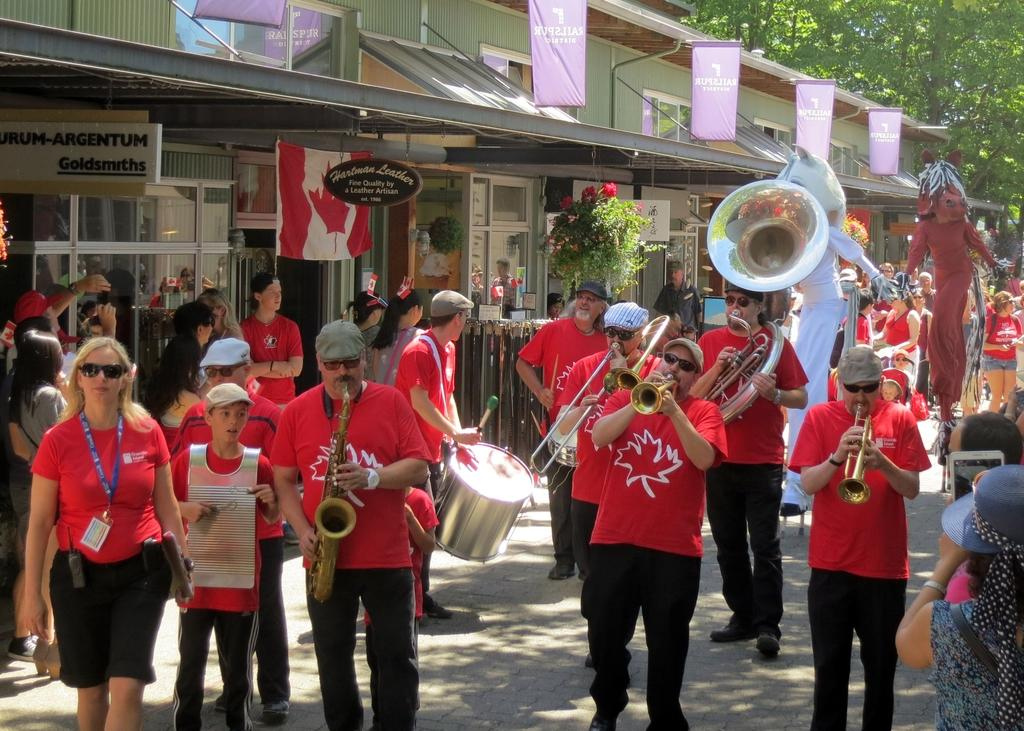What are the people in the image doing? The people in the image are playing musical instruments. Where are they playing? They are playing on the road. What can be seen in the background of the image? There is a building, flags, and trees in the background of the image. How many chickens are participating in the protest in the image? There are no chickens or protests present in the image. 